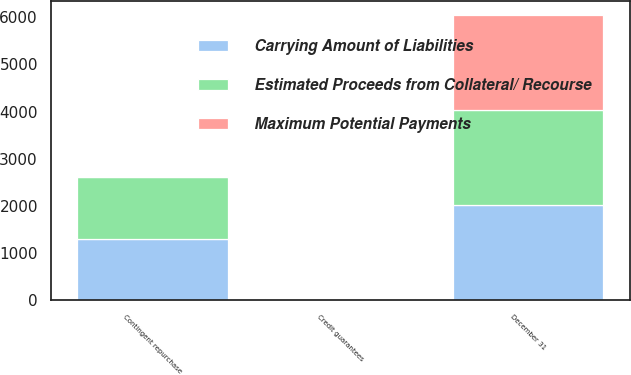Convert chart to OTSL. <chart><loc_0><loc_0><loc_500><loc_500><stacked_bar_chart><ecel><fcel>December 31<fcel>Contingent repurchase<fcel>Credit guarantees<nl><fcel>Carrying Amount of Liabilities<fcel>2016<fcel>1306<fcel>29<nl><fcel>Estimated Proceeds from Collateral/ Recourse<fcel>2016<fcel>1306<fcel>27<nl><fcel>Maximum Potential Payments<fcel>2016<fcel>9<fcel>2<nl></chart> 